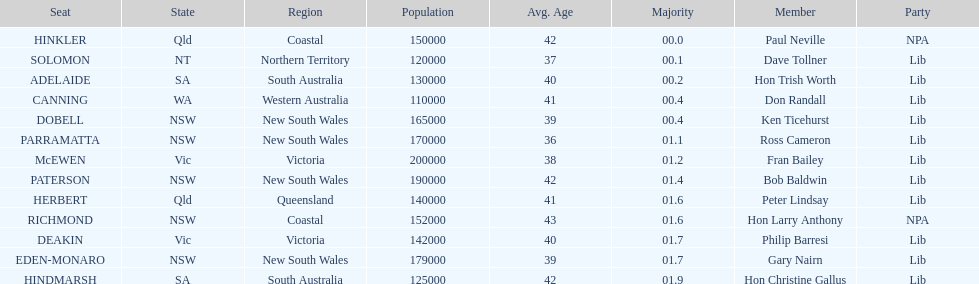What is the name of the last seat? HINDMARSH. Would you mind parsing the complete table? {'header': ['Seat', 'State', 'Region', 'Population', 'Avg. Age', 'Majority', 'Member', 'Party'], 'rows': [['HINKLER', 'Qld', 'Coastal', '150000', '42', '00.0', 'Paul Neville', 'NPA'], ['SOLOMON', 'NT', 'Northern Territory', '120000', '37', '00.1', 'Dave Tollner', 'Lib'], ['ADELAIDE', 'SA', 'South Australia', '130000', '40', '00.2', 'Hon Trish Worth', 'Lib'], ['CANNING', 'WA', 'Western Australia', '110000', '41', '00.4', 'Don Randall', 'Lib'], ['DOBELL', 'NSW', 'New South Wales', '165000', '39', '00.4', 'Ken Ticehurst', 'Lib'], ['PARRAMATTA', 'NSW', 'New South Wales', '170000', '36', '01.1', 'Ross Cameron', 'Lib'], ['McEWEN', 'Vic', 'Victoria', '200000', '38', '01.2', 'Fran Bailey', 'Lib'], ['PATERSON', 'NSW', 'New South Wales', '190000', '42', '01.4', 'Bob Baldwin', 'Lib'], ['HERBERT', 'Qld', 'Queensland', '140000', '41', '01.6', 'Peter Lindsay', 'Lib'], ['RICHMOND', 'NSW', 'Coastal', '152000', '43', '01.6', 'Hon Larry Anthony', 'NPA'], ['DEAKIN', 'Vic', 'Victoria', '142000', '40', '01.7', 'Philip Barresi', 'Lib'], ['EDEN-MONARO', 'NSW', 'New South Wales', '179000', '39', '01.7', 'Gary Nairn', 'Lib'], ['HINDMARSH', 'SA', 'South Australia', '125000', '42', '01.9', 'Hon Christine Gallus', 'Lib']]} 